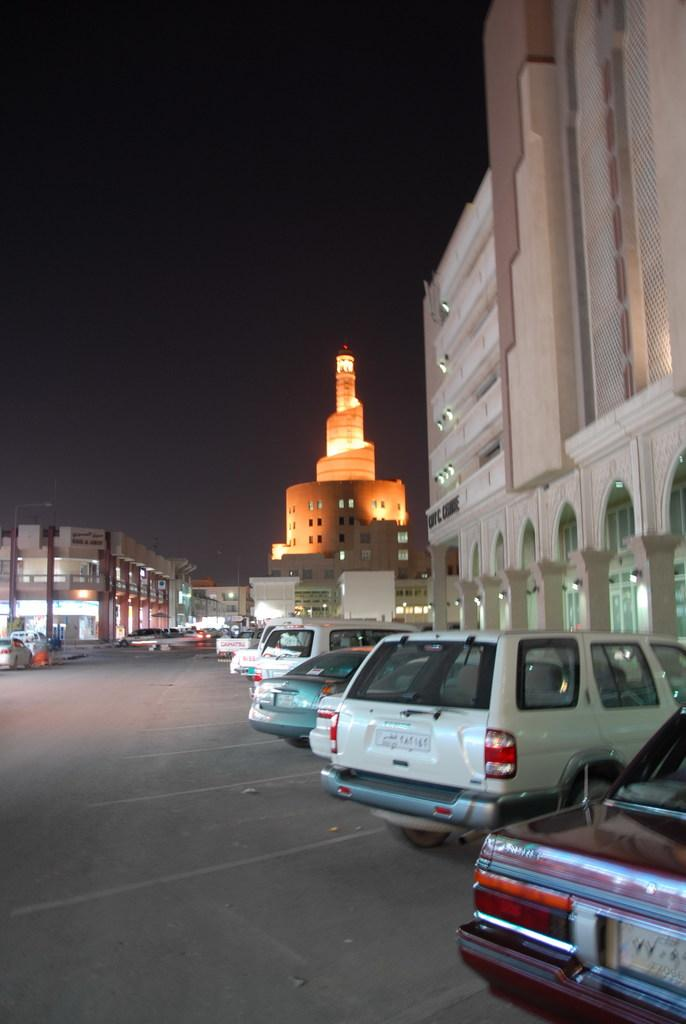What can be seen on the road in the image? There are vehicles on the road in the image. What type of structures are visible in the image? There are buildings visible in the image. What is visible at the top of the image? The sky is visible at the top of the image. What type of bed can be seen in the image? There is no bed present in the image. What type of print is visible on the vehicles in the image? The image does not provide enough detail to determine the type of print on the vehicles. 